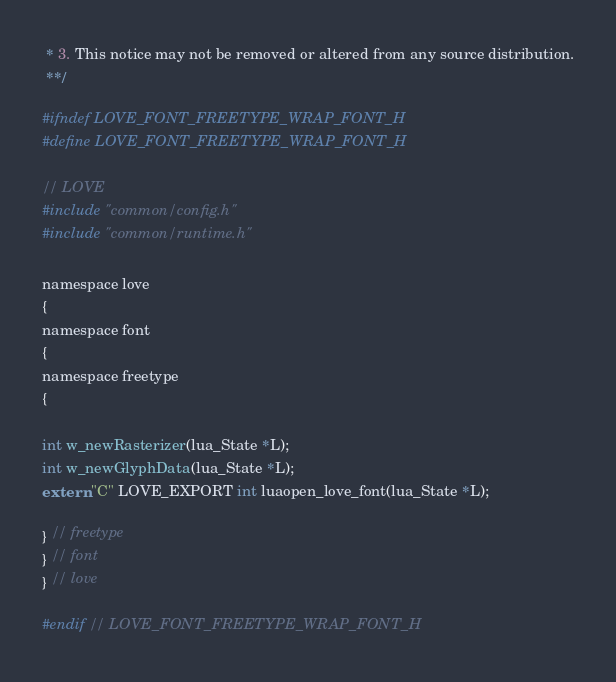<code> <loc_0><loc_0><loc_500><loc_500><_C_> * 3. This notice may not be removed or altered from any source distribution.
 **/

#ifndef LOVE_FONT_FREETYPE_WRAP_FONT_H
#define LOVE_FONT_FREETYPE_WRAP_FONT_H

// LOVE
#include "common/config.h"
#include "common/runtime.h"

namespace love
{
namespace font
{
namespace freetype
{

int w_newRasterizer(lua_State *L);
int w_newGlyphData(lua_State *L);
extern "C" LOVE_EXPORT int luaopen_love_font(lua_State *L);

} // freetype
} // font
} // love

#endif // LOVE_FONT_FREETYPE_WRAP_FONT_H
</code> 